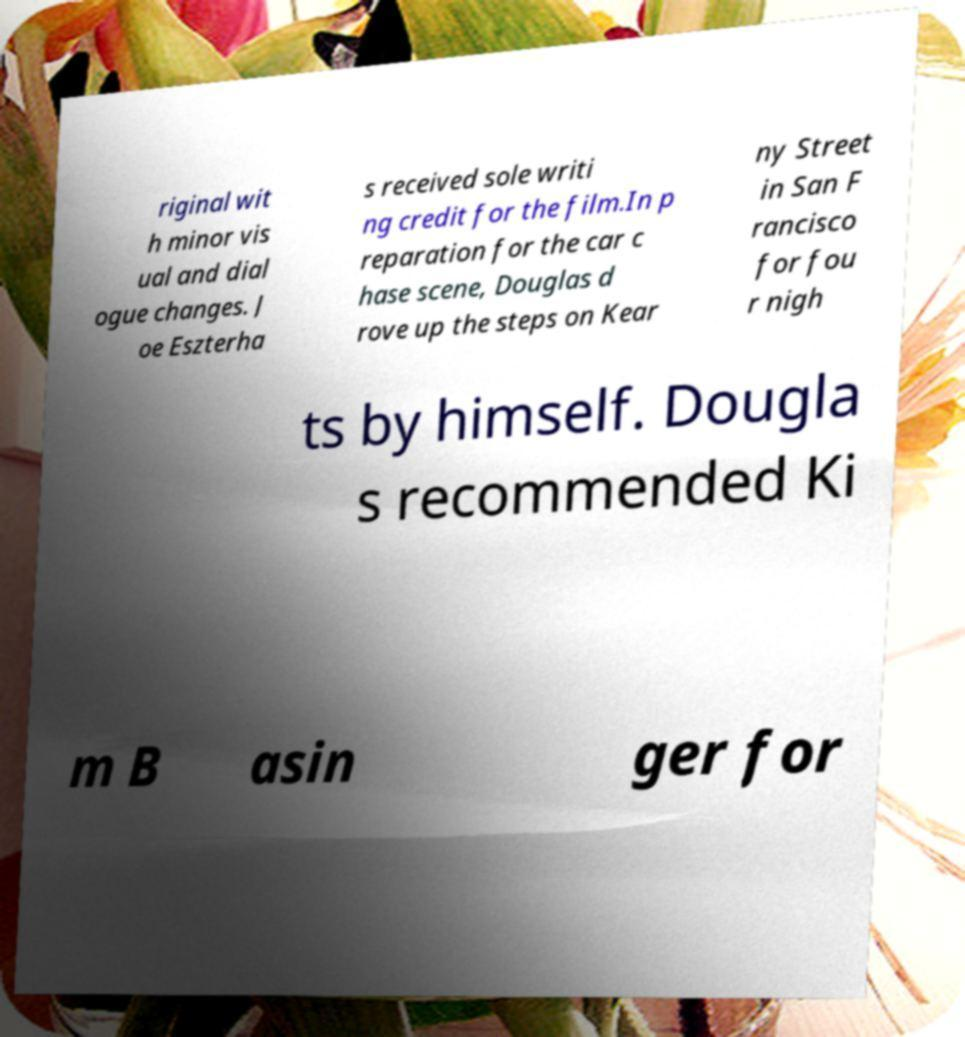I need the written content from this picture converted into text. Can you do that? riginal wit h minor vis ual and dial ogue changes. J oe Eszterha s received sole writi ng credit for the film.In p reparation for the car c hase scene, Douglas d rove up the steps on Kear ny Street in San F rancisco for fou r nigh ts by himself. Dougla s recommended Ki m B asin ger for 